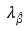<formula> <loc_0><loc_0><loc_500><loc_500>\lambda _ { \hat { \beta } }</formula> 